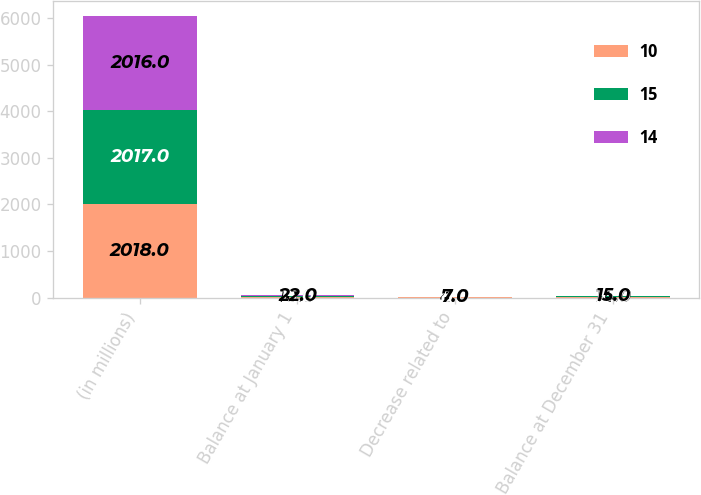Convert chart. <chart><loc_0><loc_0><loc_500><loc_500><stacked_bar_chart><ecel><fcel>(in millions)<fcel>Balance at January 1<fcel>Decrease related to<fcel>Balance at December 31<nl><fcel>10<fcel>2018<fcel>10<fcel>4<fcel>14<nl><fcel>15<fcel>2017<fcel>15<fcel>8<fcel>10<nl><fcel>14<fcel>2016<fcel>22<fcel>7<fcel>15<nl></chart> 